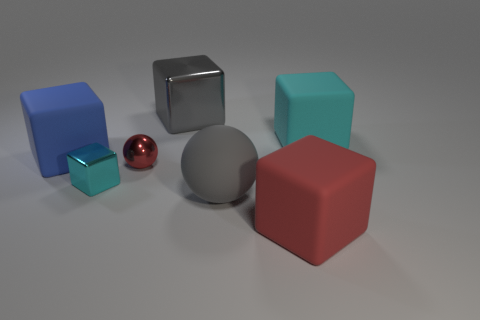Is there any other thing that has the same color as the large ball?
Give a very brief answer. Yes. Is the size of the cyan block in front of the blue rubber object the same as the tiny metal ball?
Your answer should be compact. Yes. How many large blue rubber things are right of the metal thing that is in front of the small sphere?
Ensure brevity in your answer.  0. Are there any large cyan matte cubes that are left of the rubber block that is to the right of the large object in front of the gray sphere?
Your response must be concise. No. What is the material of the other tiny thing that is the same shape as the red rubber thing?
Make the answer very short. Metal. Are the blue block and the large gray thing behind the blue thing made of the same material?
Offer a very short reply. No. There is a big gray thing behind the cyan cube that is behind the big blue matte cube; what is its shape?
Ensure brevity in your answer.  Cube. How many small objects are either cyan matte cubes or red shiny things?
Make the answer very short. 1. What number of tiny cyan shiny things have the same shape as the large gray rubber object?
Offer a very short reply. 0. Is the shape of the cyan metallic thing the same as the large gray thing on the right side of the big metallic cube?
Offer a terse response. No. 